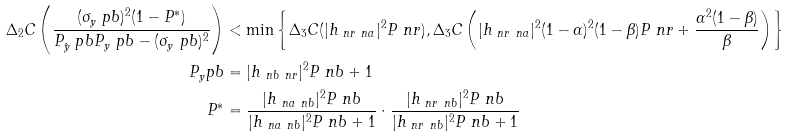<formula> <loc_0><loc_0><loc_500><loc_500>\Delta _ { 2 } C \left ( \frac { ( \sigma _ { y } ^ { \ } p b ) ^ { 2 } ( 1 - P ^ { * } ) } { P _ { \hat { y } } ^ { \ } p b P _ { y } ^ { \ } p b - ( \sigma _ { y } ^ { \ } p b ) ^ { 2 } } \right ) & < \min \left \{ \Delta _ { 3 } C ( | h _ { \ n r \ n a } | ^ { 2 } P _ { \ } n r ) , \Delta _ { 3 } C \left ( | h _ { \ n r \ n a } | ^ { 2 } ( 1 - \alpha ) ^ { 2 } ( 1 - \beta ) P _ { \ } n r + \frac { \alpha ^ { 2 } ( 1 - \beta ) } { \beta } \right ) \right \} \\ \ P _ { y } ^ { \ } p b & = | h _ { \ n b \ n r } | ^ { 2 } P _ { \ } n b + 1 \\ P ^ { * } & = \frac { | h _ { \ n a \ n b } | ^ { 2 } P _ { \ } n b } { | h _ { \ n a \ n b } | ^ { 2 } P _ { \ } n b + 1 } \cdot \frac { | h _ { \ n r \ n b } | ^ { 2 } P _ { \ } n b } { | h _ { \ n r \ n b } | ^ { 2 } P _ { \ } n b + 1 }</formula> 